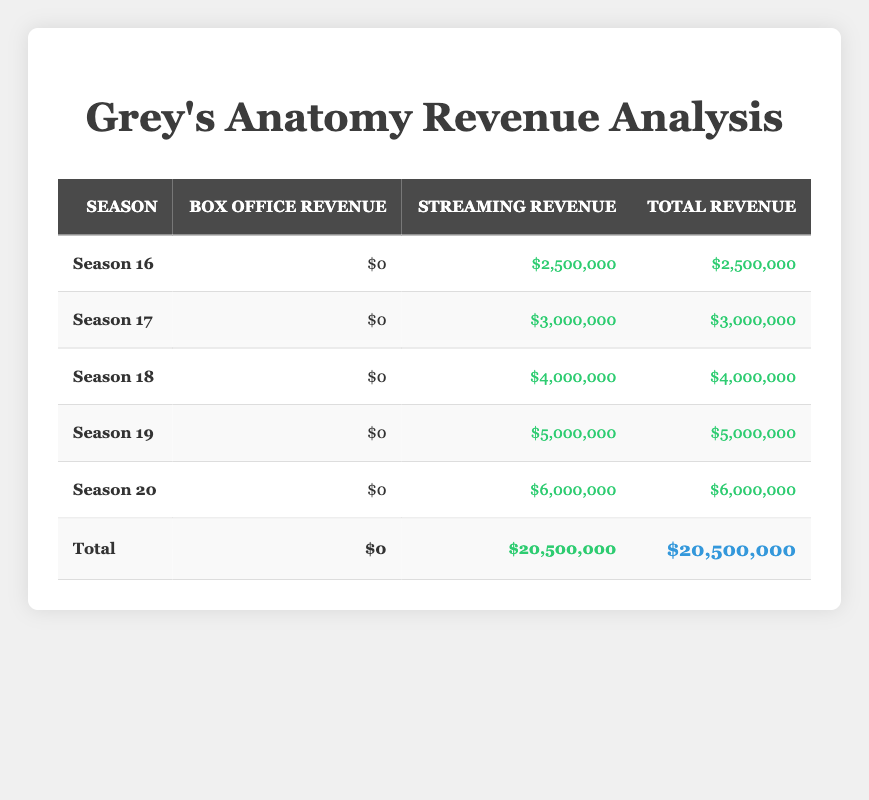What is the total box office revenue for Grey's Anatomy over the last five seasons? The data shows that the box office revenue for each of the five seasons is zero. Therefore, when we sum up these values, the total remains zero.
Answer: 0 What was the streaming revenue for Season 19? Referring to the table, the streaming revenue for Season 19 is listed as 5,000,000.
Answer: 5,000,000 Which season had the highest streaming revenue? By examining each season's streaming revenue, we observe that Season 20 has the highest amount at 6,000,000, compared to the other seasons.
Answer: Season 20 What is the total streaming revenue across all seasons? The total streaming revenue column in the table indicates that when we sum the streaming revenue of all seasons (2,500,000 + 3,000,000 + 4,000,000 + 5,000,000 + 6,000,000), we arrive at 20,500,000.
Answer: 20,500,000 Is the total revenue from streaming greater than the total box office revenue? The total revenue from streaming is 20,500,000, and the total box office revenue is 0. Since 20,500,000 is greater than 0, the answer is yes.
Answer: Yes What is the average box office revenue per season? Since the box office revenue for each season is zero, the average is simply 0 divided by 5 seasons, which results in 0.
Answer: 0 How much more streaming revenue did Season 20 earn compared to Season 16? The streaming revenue for Season 20 is 6,000,000, while for Season 16 it is 2,500,000. The difference is 6,000,000 - 2,500,000, resulting in 3,500,000.
Answer: 3,500,000 Which season contributed the least to the total revenue? All seasons contributed equally to the box office revenue, which is zero, but for streaming, Season 16 contributed the least with 2,500,000. Hence, considering total revenue, Season 16 is the least contributor.
Answer: Season 16 What percentage of the total revenue is derived from streaming? The total revenue is 20,500,000, and all of it comes from streaming, so to find the percentage we compute (20,500,000 / 20,500,000) * 100, which equals 100%.
Answer: 100% 